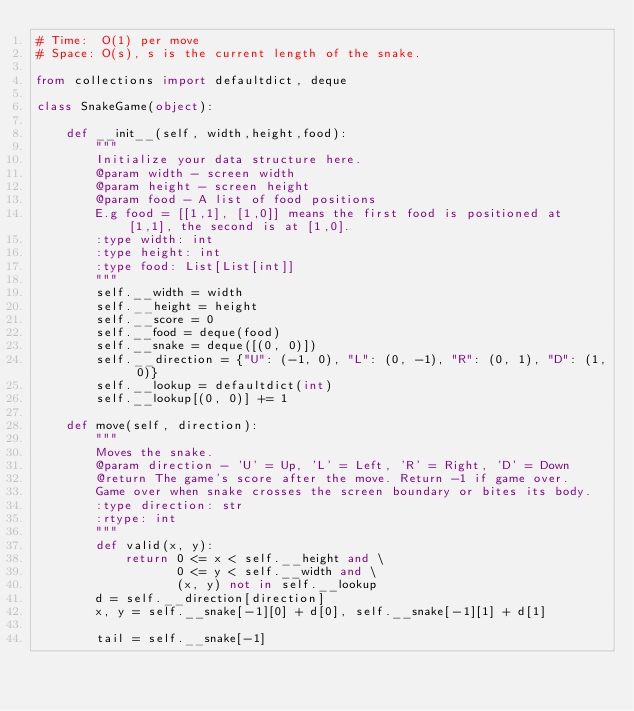<code> <loc_0><loc_0><loc_500><loc_500><_Python_># Time:  O(1) per move
# Space: O(s), s is the current length of the snake.

from collections import defaultdict, deque

class SnakeGame(object):

    def __init__(self, width,height,food):
        """
        Initialize your data structure here.
        @param width - screen width
        @param height - screen height
        @param food - A list of food positions
        E.g food = [[1,1], [1,0]] means the first food is positioned at [1,1], the second is at [1,0].
        :type width: int
        :type height: int
        :type food: List[List[int]]
        """
        self.__width = width
        self.__height = height
        self.__score = 0
        self.__food = deque(food)
        self.__snake = deque([(0, 0)])
        self.__direction = {"U": (-1, 0), "L": (0, -1), "R": (0, 1), "D": (1, 0)}
        self.__lookup = defaultdict(int)
        self.__lookup[(0, 0)] += 1

    def move(self, direction):
        """
        Moves the snake.
        @param direction - 'U' = Up, 'L' = Left, 'R' = Right, 'D' = Down
        @return The game's score after the move. Return -1 if game over.
        Game over when snake crosses the screen boundary or bites its body.
        :type direction: str
        :rtype: int
        """
        def valid(x, y):
            return 0 <= x < self.__height and \
                   0 <= y < self.__width and \
                   (x, y) not in self.__lookup
        d = self.__direction[direction]
        x, y = self.__snake[-1][0] + d[0], self.__snake[-1][1] + d[1]

        tail = self.__snake[-1]</code> 